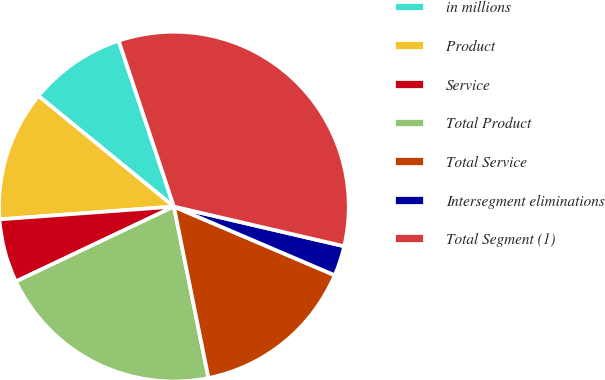Convert chart. <chart><loc_0><loc_0><loc_500><loc_500><pie_chart><fcel>in millions<fcel>Product<fcel>Service<fcel>Total Product<fcel>Total Service<fcel>Intersegment eliminations<fcel>Total Segment (1)<nl><fcel>8.98%<fcel>12.07%<fcel>5.88%<fcel>21.12%<fcel>15.41%<fcel>2.78%<fcel>33.75%<nl></chart> 